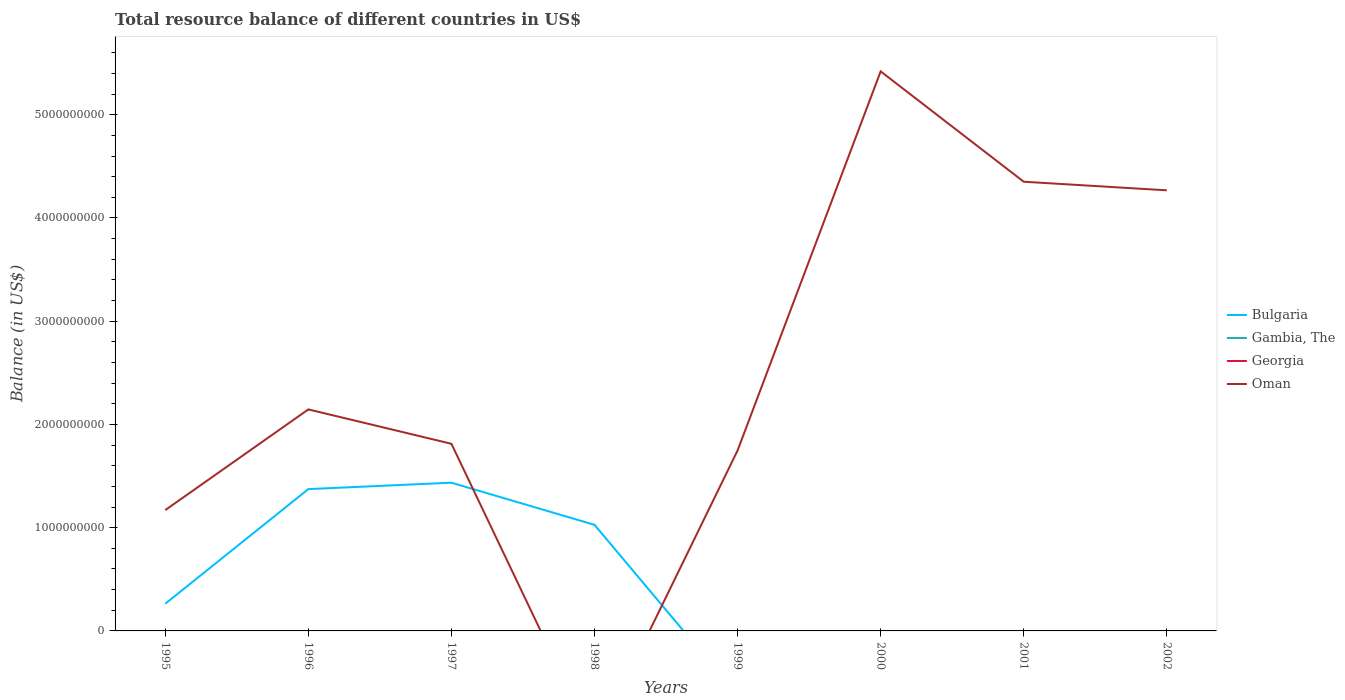Does the line corresponding to Oman intersect with the line corresponding to Georgia?
Give a very brief answer. Yes. Is the number of lines equal to the number of legend labels?
Offer a terse response. No. Across all years, what is the maximum total resource balance in Bulgaria?
Your response must be concise. 0. What is the total total resource balance in Oman in the graph?
Your response must be concise. -5.77e+08. What is the difference between the highest and the second highest total resource balance in Oman?
Give a very brief answer. 5.42e+09. Is the total resource balance in Georgia strictly greater than the total resource balance in Bulgaria over the years?
Your response must be concise. No. What is the difference between two consecutive major ticks on the Y-axis?
Keep it short and to the point. 1.00e+09. How many legend labels are there?
Offer a terse response. 4. What is the title of the graph?
Give a very brief answer. Total resource balance of different countries in US$. Does "High income: nonOECD" appear as one of the legend labels in the graph?
Keep it short and to the point. No. What is the label or title of the X-axis?
Make the answer very short. Years. What is the label or title of the Y-axis?
Provide a short and direct response. Balance (in US$). What is the Balance (in US$) in Bulgaria in 1995?
Provide a succinct answer. 2.63e+08. What is the Balance (in US$) of Georgia in 1995?
Your answer should be very brief. 0. What is the Balance (in US$) of Oman in 1995?
Provide a succinct answer. 1.17e+09. What is the Balance (in US$) in Bulgaria in 1996?
Your answer should be very brief. 1.37e+09. What is the Balance (in US$) of Oman in 1996?
Give a very brief answer. 2.15e+09. What is the Balance (in US$) in Bulgaria in 1997?
Keep it short and to the point. 1.44e+09. What is the Balance (in US$) of Georgia in 1997?
Ensure brevity in your answer.  0. What is the Balance (in US$) in Oman in 1997?
Offer a terse response. 1.81e+09. What is the Balance (in US$) of Bulgaria in 1998?
Your answer should be compact. 1.03e+09. What is the Balance (in US$) in Gambia, The in 1998?
Offer a very short reply. 0. What is the Balance (in US$) in Georgia in 1998?
Your response must be concise. 0. What is the Balance (in US$) of Bulgaria in 1999?
Ensure brevity in your answer.  0. What is the Balance (in US$) in Gambia, The in 1999?
Ensure brevity in your answer.  0. What is the Balance (in US$) of Georgia in 1999?
Provide a short and direct response. 0. What is the Balance (in US$) of Oman in 1999?
Your answer should be very brief. 1.75e+09. What is the Balance (in US$) of Georgia in 2000?
Ensure brevity in your answer.  0. What is the Balance (in US$) of Oman in 2000?
Your answer should be very brief. 5.42e+09. What is the Balance (in US$) in Bulgaria in 2001?
Provide a succinct answer. 0. What is the Balance (in US$) of Gambia, The in 2001?
Make the answer very short. 0. What is the Balance (in US$) of Oman in 2001?
Your response must be concise. 4.35e+09. What is the Balance (in US$) in Gambia, The in 2002?
Provide a succinct answer. 0. What is the Balance (in US$) of Oman in 2002?
Ensure brevity in your answer.  4.27e+09. Across all years, what is the maximum Balance (in US$) of Bulgaria?
Give a very brief answer. 1.44e+09. Across all years, what is the maximum Balance (in US$) in Oman?
Your answer should be compact. 5.42e+09. Across all years, what is the minimum Balance (in US$) in Oman?
Offer a very short reply. 0. What is the total Balance (in US$) of Bulgaria in the graph?
Your response must be concise. 4.10e+09. What is the total Balance (in US$) in Georgia in the graph?
Make the answer very short. 0. What is the total Balance (in US$) in Oman in the graph?
Your response must be concise. 2.09e+1. What is the difference between the Balance (in US$) in Bulgaria in 1995 and that in 1996?
Ensure brevity in your answer.  -1.11e+09. What is the difference between the Balance (in US$) in Oman in 1995 and that in 1996?
Give a very brief answer. -9.75e+08. What is the difference between the Balance (in US$) of Bulgaria in 1995 and that in 1997?
Give a very brief answer. -1.17e+09. What is the difference between the Balance (in US$) of Oman in 1995 and that in 1997?
Your answer should be very brief. -6.42e+08. What is the difference between the Balance (in US$) in Bulgaria in 1995 and that in 1998?
Provide a short and direct response. -7.65e+08. What is the difference between the Balance (in US$) in Oman in 1995 and that in 1999?
Make the answer very short. -5.77e+08. What is the difference between the Balance (in US$) of Oman in 1995 and that in 2000?
Provide a short and direct response. -4.25e+09. What is the difference between the Balance (in US$) of Oman in 1995 and that in 2001?
Make the answer very short. -3.18e+09. What is the difference between the Balance (in US$) of Oman in 1995 and that in 2002?
Offer a very short reply. -3.10e+09. What is the difference between the Balance (in US$) in Bulgaria in 1996 and that in 1997?
Your answer should be compact. -6.22e+07. What is the difference between the Balance (in US$) in Oman in 1996 and that in 1997?
Your response must be concise. 3.33e+08. What is the difference between the Balance (in US$) of Bulgaria in 1996 and that in 1998?
Give a very brief answer. 3.46e+08. What is the difference between the Balance (in US$) in Oman in 1996 and that in 1999?
Offer a terse response. 3.98e+08. What is the difference between the Balance (in US$) of Oman in 1996 and that in 2000?
Your answer should be compact. -3.27e+09. What is the difference between the Balance (in US$) of Oman in 1996 and that in 2001?
Your answer should be very brief. -2.21e+09. What is the difference between the Balance (in US$) in Oman in 1996 and that in 2002?
Offer a very short reply. -2.12e+09. What is the difference between the Balance (in US$) in Bulgaria in 1997 and that in 1998?
Make the answer very short. 4.08e+08. What is the difference between the Balance (in US$) of Oman in 1997 and that in 1999?
Your answer should be compact. 6.50e+07. What is the difference between the Balance (in US$) in Oman in 1997 and that in 2000?
Provide a short and direct response. -3.61e+09. What is the difference between the Balance (in US$) of Oman in 1997 and that in 2001?
Your answer should be very brief. -2.54e+09. What is the difference between the Balance (in US$) of Oman in 1997 and that in 2002?
Ensure brevity in your answer.  -2.46e+09. What is the difference between the Balance (in US$) in Oman in 1999 and that in 2000?
Keep it short and to the point. -3.67e+09. What is the difference between the Balance (in US$) of Oman in 1999 and that in 2001?
Provide a short and direct response. -2.60e+09. What is the difference between the Balance (in US$) in Oman in 1999 and that in 2002?
Your answer should be compact. -2.52e+09. What is the difference between the Balance (in US$) in Oman in 2000 and that in 2001?
Make the answer very short. 1.07e+09. What is the difference between the Balance (in US$) of Oman in 2000 and that in 2002?
Give a very brief answer. 1.15e+09. What is the difference between the Balance (in US$) in Oman in 2001 and that in 2002?
Keep it short and to the point. 8.32e+07. What is the difference between the Balance (in US$) of Bulgaria in 1995 and the Balance (in US$) of Oman in 1996?
Make the answer very short. -1.88e+09. What is the difference between the Balance (in US$) of Bulgaria in 1995 and the Balance (in US$) of Oman in 1997?
Provide a succinct answer. -1.55e+09. What is the difference between the Balance (in US$) in Bulgaria in 1995 and the Balance (in US$) in Oman in 1999?
Keep it short and to the point. -1.48e+09. What is the difference between the Balance (in US$) of Bulgaria in 1995 and the Balance (in US$) of Oman in 2000?
Keep it short and to the point. -5.16e+09. What is the difference between the Balance (in US$) of Bulgaria in 1995 and the Balance (in US$) of Oman in 2001?
Make the answer very short. -4.09e+09. What is the difference between the Balance (in US$) of Bulgaria in 1995 and the Balance (in US$) of Oman in 2002?
Keep it short and to the point. -4.00e+09. What is the difference between the Balance (in US$) of Bulgaria in 1996 and the Balance (in US$) of Oman in 1997?
Your answer should be compact. -4.39e+08. What is the difference between the Balance (in US$) of Bulgaria in 1996 and the Balance (in US$) of Oman in 1999?
Offer a terse response. -3.74e+08. What is the difference between the Balance (in US$) in Bulgaria in 1996 and the Balance (in US$) in Oman in 2000?
Keep it short and to the point. -4.05e+09. What is the difference between the Balance (in US$) in Bulgaria in 1996 and the Balance (in US$) in Oman in 2001?
Make the answer very short. -2.98e+09. What is the difference between the Balance (in US$) in Bulgaria in 1996 and the Balance (in US$) in Oman in 2002?
Provide a short and direct response. -2.89e+09. What is the difference between the Balance (in US$) of Bulgaria in 1997 and the Balance (in US$) of Oman in 1999?
Your answer should be very brief. -3.12e+08. What is the difference between the Balance (in US$) of Bulgaria in 1997 and the Balance (in US$) of Oman in 2000?
Give a very brief answer. -3.98e+09. What is the difference between the Balance (in US$) in Bulgaria in 1997 and the Balance (in US$) in Oman in 2001?
Your response must be concise. -2.92e+09. What is the difference between the Balance (in US$) of Bulgaria in 1997 and the Balance (in US$) of Oman in 2002?
Ensure brevity in your answer.  -2.83e+09. What is the difference between the Balance (in US$) in Bulgaria in 1998 and the Balance (in US$) in Oman in 1999?
Make the answer very short. -7.20e+08. What is the difference between the Balance (in US$) of Bulgaria in 1998 and the Balance (in US$) of Oman in 2000?
Provide a short and direct response. -4.39e+09. What is the difference between the Balance (in US$) in Bulgaria in 1998 and the Balance (in US$) in Oman in 2001?
Provide a succinct answer. -3.32e+09. What is the difference between the Balance (in US$) of Bulgaria in 1998 and the Balance (in US$) of Oman in 2002?
Make the answer very short. -3.24e+09. What is the average Balance (in US$) in Bulgaria per year?
Your answer should be very brief. 5.13e+08. What is the average Balance (in US$) of Gambia, The per year?
Offer a very short reply. 0. What is the average Balance (in US$) in Georgia per year?
Provide a short and direct response. 0. What is the average Balance (in US$) in Oman per year?
Offer a very short reply. 2.61e+09. In the year 1995, what is the difference between the Balance (in US$) of Bulgaria and Balance (in US$) of Oman?
Keep it short and to the point. -9.07e+08. In the year 1996, what is the difference between the Balance (in US$) of Bulgaria and Balance (in US$) of Oman?
Your response must be concise. -7.72e+08. In the year 1997, what is the difference between the Balance (in US$) in Bulgaria and Balance (in US$) in Oman?
Provide a succinct answer. -3.77e+08. What is the ratio of the Balance (in US$) of Bulgaria in 1995 to that in 1996?
Make the answer very short. 0.19. What is the ratio of the Balance (in US$) in Oman in 1995 to that in 1996?
Keep it short and to the point. 0.55. What is the ratio of the Balance (in US$) of Bulgaria in 1995 to that in 1997?
Your response must be concise. 0.18. What is the ratio of the Balance (in US$) of Oman in 1995 to that in 1997?
Ensure brevity in your answer.  0.65. What is the ratio of the Balance (in US$) of Bulgaria in 1995 to that in 1998?
Offer a terse response. 0.26. What is the ratio of the Balance (in US$) of Oman in 1995 to that in 1999?
Offer a terse response. 0.67. What is the ratio of the Balance (in US$) in Oman in 1995 to that in 2000?
Your response must be concise. 0.22. What is the ratio of the Balance (in US$) in Oman in 1995 to that in 2001?
Offer a terse response. 0.27. What is the ratio of the Balance (in US$) in Oman in 1995 to that in 2002?
Your response must be concise. 0.27. What is the ratio of the Balance (in US$) of Bulgaria in 1996 to that in 1997?
Keep it short and to the point. 0.96. What is the ratio of the Balance (in US$) of Oman in 1996 to that in 1997?
Your answer should be very brief. 1.18. What is the ratio of the Balance (in US$) of Bulgaria in 1996 to that in 1998?
Give a very brief answer. 1.34. What is the ratio of the Balance (in US$) of Oman in 1996 to that in 1999?
Provide a succinct answer. 1.23. What is the ratio of the Balance (in US$) in Oman in 1996 to that in 2000?
Offer a terse response. 0.4. What is the ratio of the Balance (in US$) in Oman in 1996 to that in 2001?
Offer a terse response. 0.49. What is the ratio of the Balance (in US$) in Oman in 1996 to that in 2002?
Ensure brevity in your answer.  0.5. What is the ratio of the Balance (in US$) in Bulgaria in 1997 to that in 1998?
Keep it short and to the point. 1.4. What is the ratio of the Balance (in US$) of Oman in 1997 to that in 1999?
Offer a very short reply. 1.04. What is the ratio of the Balance (in US$) in Oman in 1997 to that in 2000?
Ensure brevity in your answer.  0.33. What is the ratio of the Balance (in US$) of Oman in 1997 to that in 2001?
Offer a terse response. 0.42. What is the ratio of the Balance (in US$) of Oman in 1997 to that in 2002?
Provide a succinct answer. 0.42. What is the ratio of the Balance (in US$) in Oman in 1999 to that in 2000?
Your answer should be very brief. 0.32. What is the ratio of the Balance (in US$) in Oman in 1999 to that in 2001?
Make the answer very short. 0.4. What is the ratio of the Balance (in US$) of Oman in 1999 to that in 2002?
Ensure brevity in your answer.  0.41. What is the ratio of the Balance (in US$) in Oman in 2000 to that in 2001?
Your answer should be compact. 1.25. What is the ratio of the Balance (in US$) of Oman in 2000 to that in 2002?
Your response must be concise. 1.27. What is the ratio of the Balance (in US$) in Oman in 2001 to that in 2002?
Offer a very short reply. 1.02. What is the difference between the highest and the second highest Balance (in US$) of Bulgaria?
Your answer should be compact. 6.22e+07. What is the difference between the highest and the second highest Balance (in US$) in Oman?
Keep it short and to the point. 1.07e+09. What is the difference between the highest and the lowest Balance (in US$) in Bulgaria?
Offer a very short reply. 1.44e+09. What is the difference between the highest and the lowest Balance (in US$) in Oman?
Keep it short and to the point. 5.42e+09. 